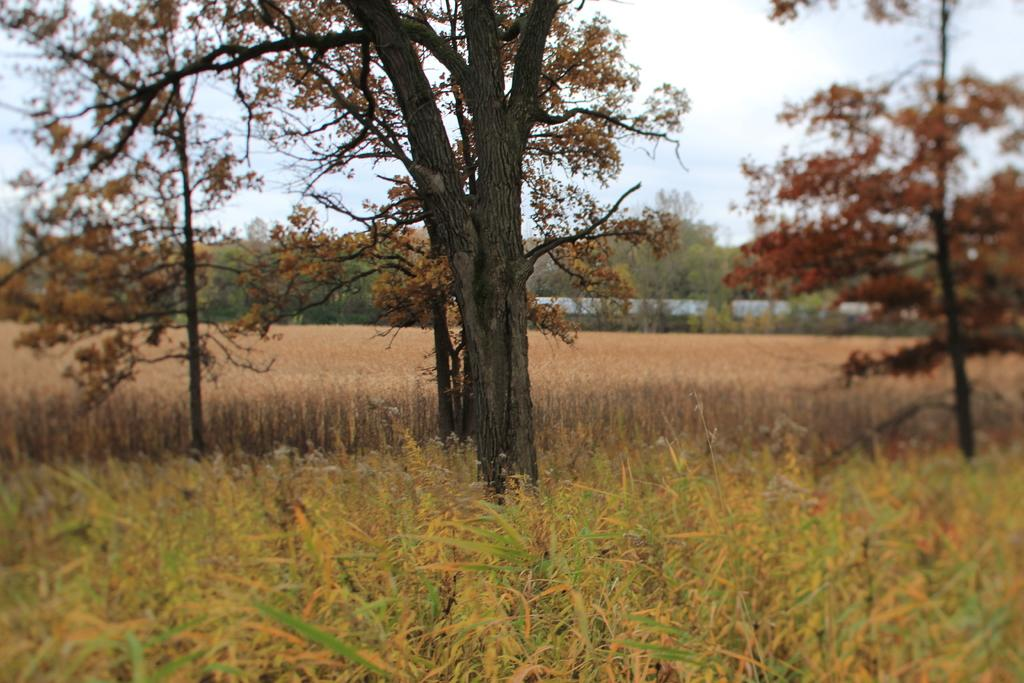What type of vegetation can be seen in the image? There are trees with branches and leaves in the image. Are there any other types of plants visible in the image? Yes, there are plants in the image. What is the condition of the grass in the image? The grass appears to be dried in the image. How many aunts are sitting on the celery in the image? There are no aunts or celery present in the image. What type of women can be seen in the image? There are no women present in the image; it features trees, plants, and grass. 